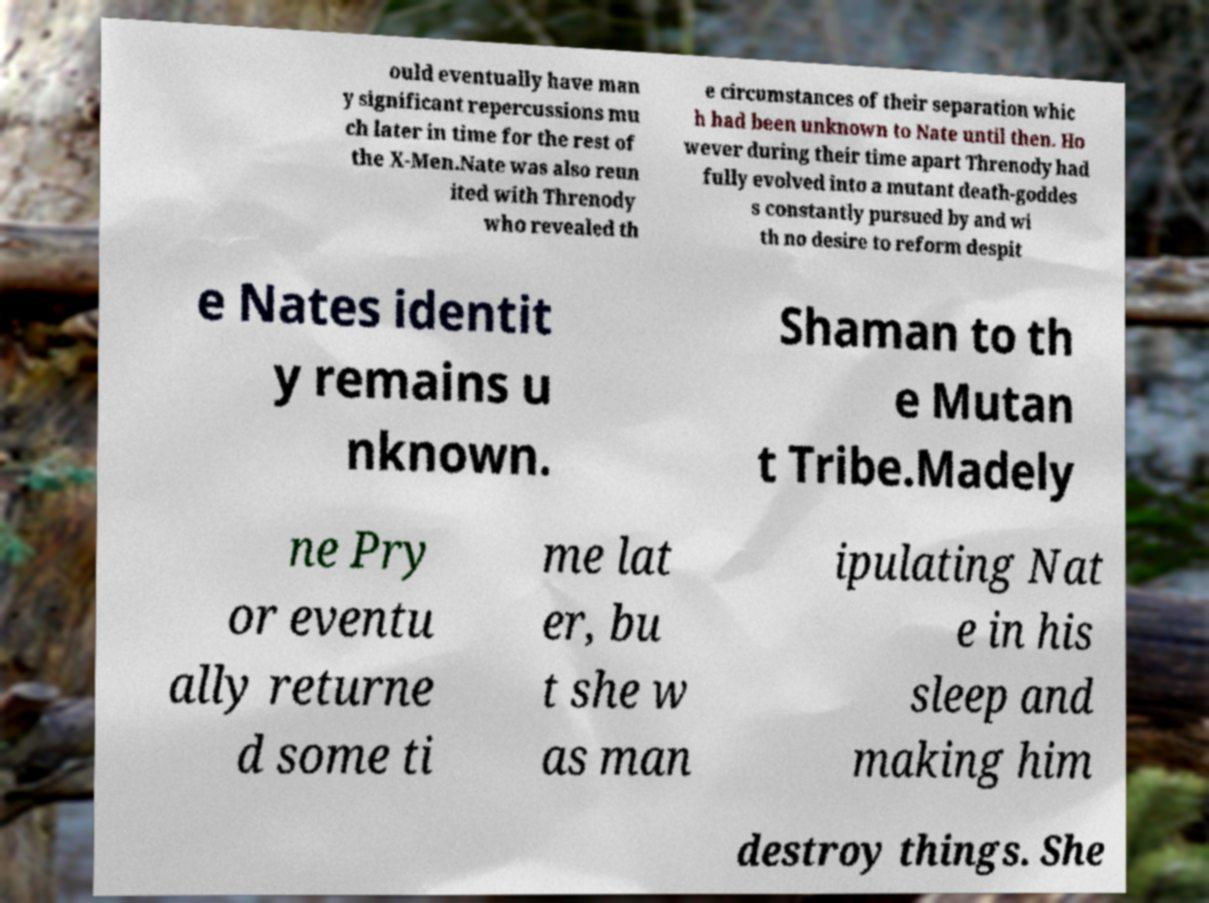I need the written content from this picture converted into text. Can you do that? ould eventually have man y significant repercussions mu ch later in time for the rest of the X-Men.Nate was also reun ited with Threnody who revealed th e circumstances of their separation whic h had been unknown to Nate until then. Ho wever during their time apart Threnody had fully evolved into a mutant death-goddes s constantly pursued by and wi th no desire to reform despit e Nates identit y remains u nknown. Shaman to th e Mutan t Tribe.Madely ne Pry or eventu ally returne d some ti me lat er, bu t she w as man ipulating Nat e in his sleep and making him destroy things. She 